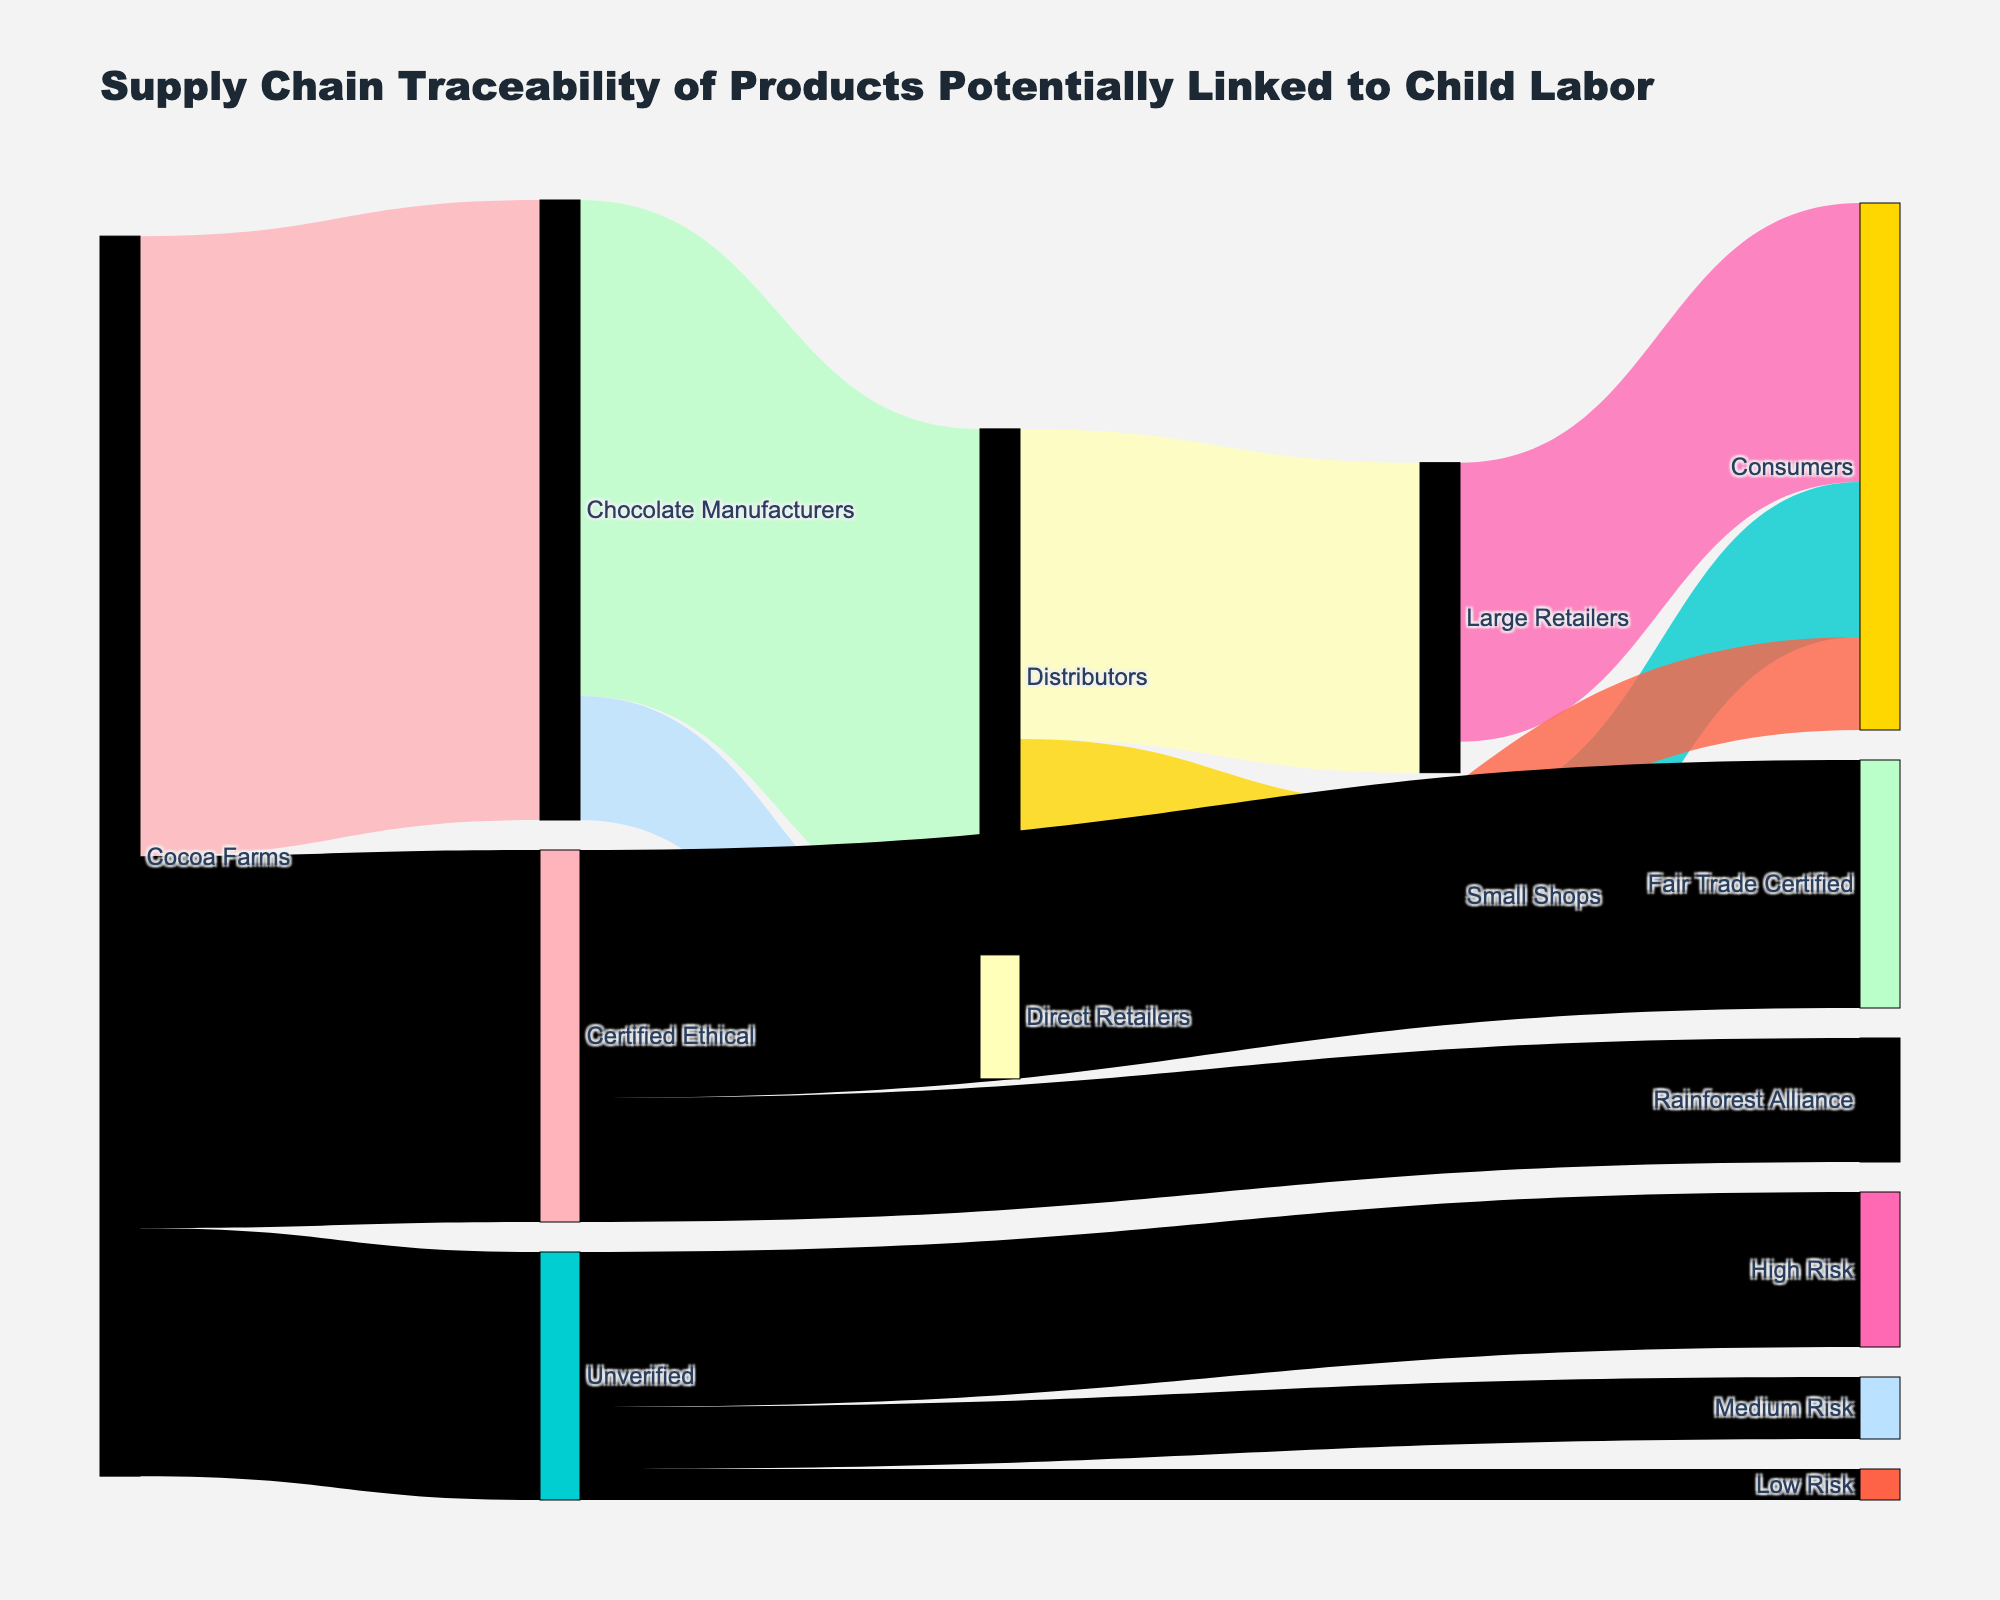what is the main title displayed on the diagram? The title located at the top of the diagram says "Supply Chain Traceability of Products Potentially Linked to Child Labor".
Answer: Supply Chain Traceability of Products Potentially Linked to Child Labor What is the value of cocoa that goes from farms to certified ethical sources? Following the flow from "Cocoa Farms" through "Traceability Audit" to "Certified Ethical", the value is marked as 60.
Answer: 60 How many destinations receive chocolate from manufacturers? The flow from "Chocolate Manufacturers" splits into two paths labeled "Distributors" and "Direct Retailers", making a total of 2 destinations.
Answer: 2 Which retailer node receives the highest amount of distributed chocolate? By comparing the value of chocolate moving from "Distributors" to "Large Retailers" (50) and "Small Shops" (30), it's clear that "Large Retailers" receives the highest amount.
Answer: Large Retailers What is the combined flow value from cocoa farms to consumers through large retailers? Following the path from "Cocoa Farms" to "Chocolate Manufacturers" (100), to "Distributors" (80), and then to "Large Retailers" (50), and finally to "Consumers" (45), the combined value at each step until reaching consumers is 45.
Answer: 45 How many paths have flows associated with risk assessment of unverified cocoa? From "Unverified" in "Risk Assessment", there are three flows to "High Risk" (25), "Medium Risk" (10), and "Low Risk" (5), making a total of 3 paths.
Answer: 3 Comparing Fair Trade Certified and Rainforest Alliance, which certification receives a larger flow value? Tracing from "Certified Ethical" to "Fair Trade Certified" (40) and to "Rainforest Alliance" (20), "Fair Trade Certified" receives a larger flow of cocoa.
Answer: Fair Trade Certified Which is the smallest value found within the Sankey Diagram? The smallest flow value can be found in the "Risk Assessment" from "Unverified" to "Low Risk", which has a value of 5.
Answer: 5 How much of the cocoa from farms is unverified? Inspecting the flow from "Cocoa Farms" to "Unverified" under "Traceability Audit" shows a value of 40.
Answer: 40 What percentage of ink distribution represents the traceability audit in the supply chain? With a total initial input of 100 cocoa from farms, the split shows 60+40 values for "Certified Ethical" and "Unverified". Therefore, traceability audit involves 100% of the initial input.
Answer: 100% 